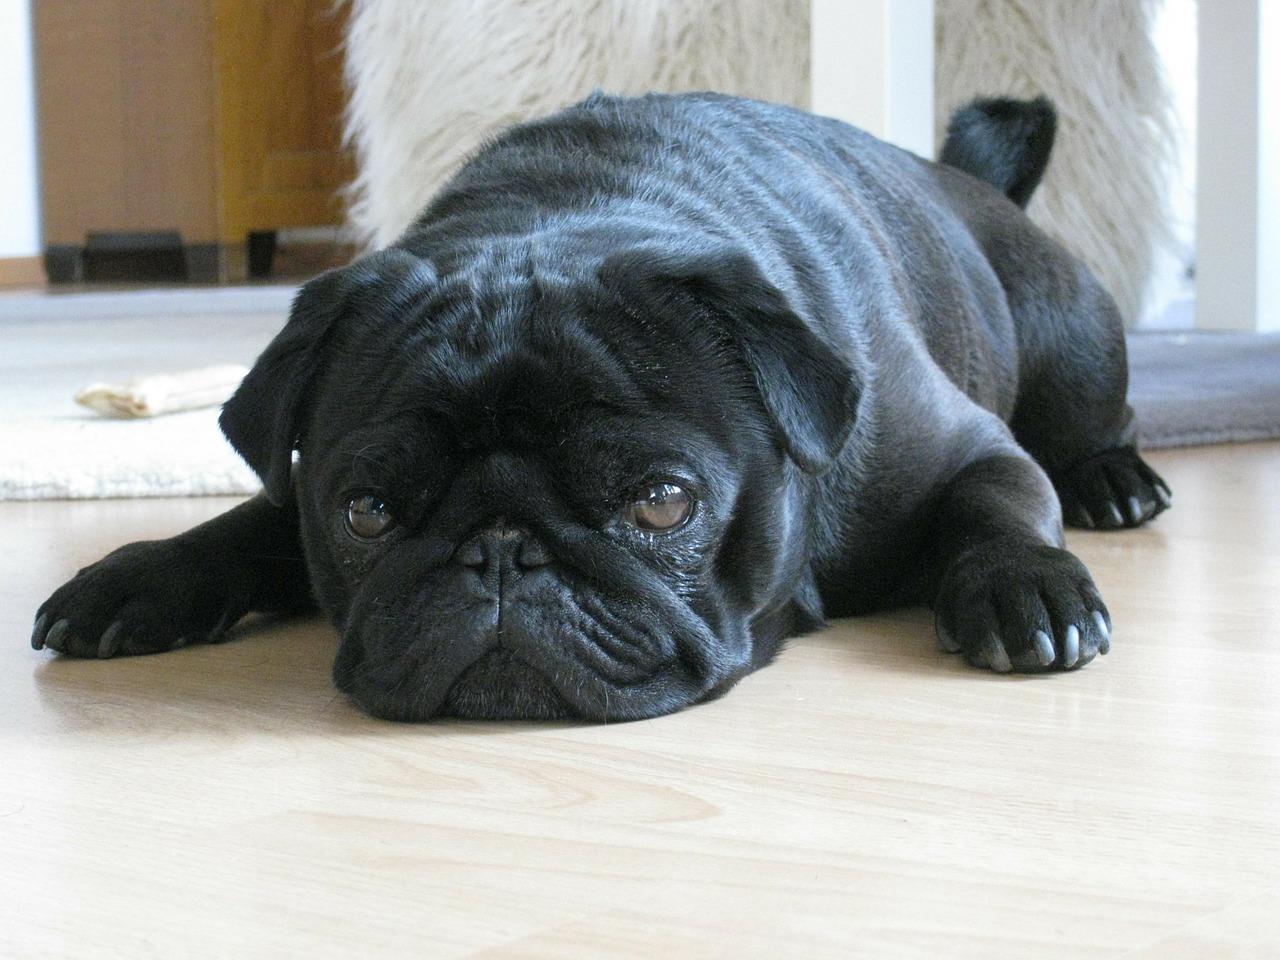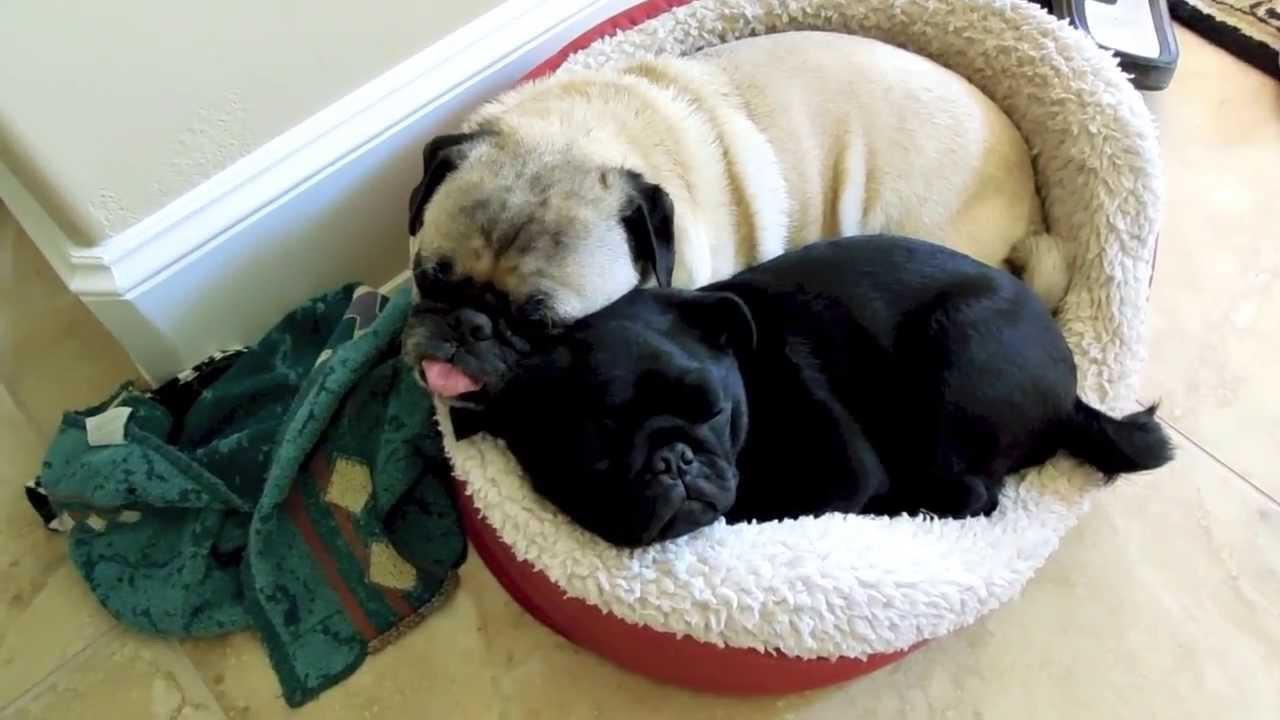The first image is the image on the left, the second image is the image on the right. For the images displayed, is the sentence "The left and right image contains the same number of tan pugs resting on their bed." factually correct? Answer yes or no. No. The first image is the image on the left, the second image is the image on the right. Evaluate the accuracy of this statement regarding the images: "The combined images include two pugs who are sleeping in a plush round pet bed.". Is it true? Answer yes or no. Yes. 